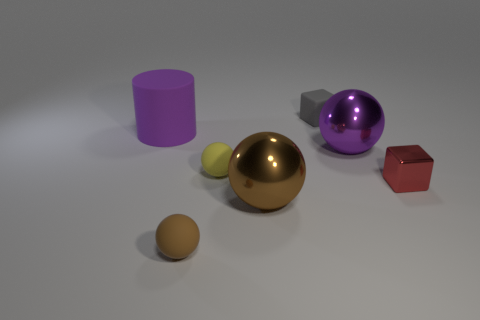Add 2 yellow rubber cylinders. How many objects exist? 9 Subtract all balls. How many objects are left? 3 Subtract all large objects. Subtract all yellow matte cylinders. How many objects are left? 4 Add 3 brown objects. How many brown objects are left? 5 Add 5 tiny brown spheres. How many tiny brown spheres exist? 6 Subtract 1 gray blocks. How many objects are left? 6 